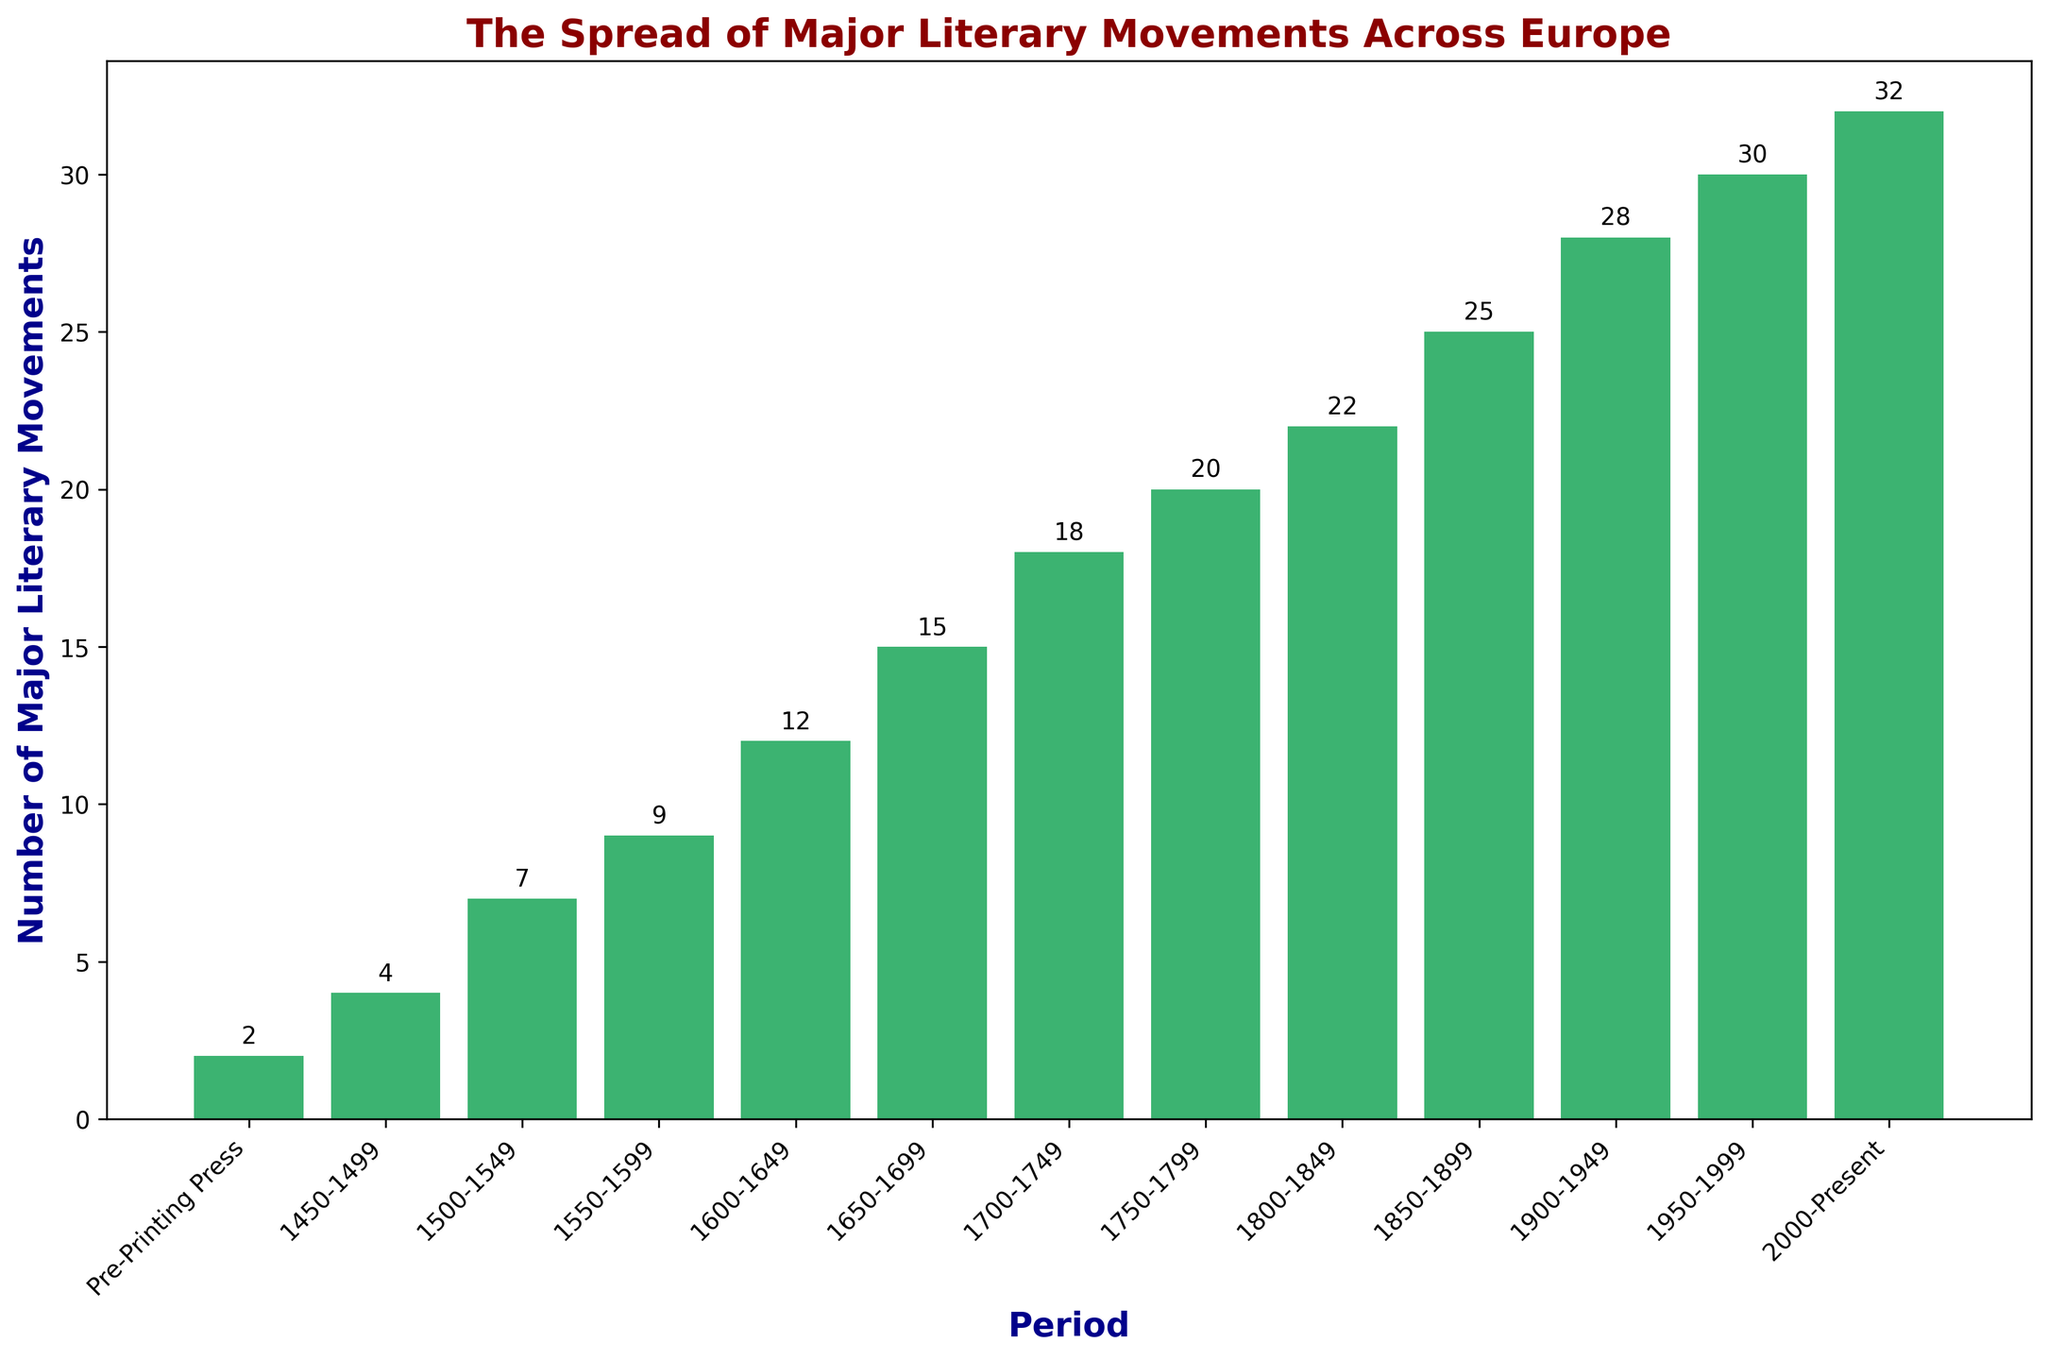What period has the highest number of major literary movements? To answer this, look at the bar with the greatest height. The tallest bar corresponds to the 2000-Present period with 32 movements. Therefore, the highest number of major literary movements is in the 2000-Present period.
Answer: 2000-Present In which period did the number of major literary movements triple compared to the Pre-Printing Press period? The Pre-Printing Press period has 2 movements. To find when it triples (2 * 3 = 6), look for the period with 6 movements. The period closest to this number is 1500-1549, which has 7 movements. Hence, during the 1500-1549 period, the number of major literary movements tripled relative to the Pre-Printing Press period.
Answer: 1500-1549 How many periods have more than 20 major literary movements? Identify the bars with heights exceeding 20. The periods 1850-1899, 1900-1949, 1950-1999, and 2000-Present all have bars taller than 20. Counting these periods gives us 4 periods.
Answer: 4 What is the total number of major literary movements from 1600 to 1849? Sum the movements in the periods from 1600-1649, 1650-1699, 1700-1749, 1750-1799, and 1800-1849. These are 12 + 15 + 18 + 20 + 22 respectively. Summing them gives 12 + 15 + 18 + 20 + 22 = 87.
Answer: 87 How many more major literary movements are there in the 20th century (1900-1999) compared to the 16th century (1500-1599)? Compare the total number of movements in 1900-1999 (28 + 30) to those in 1500-1599 (7 + 9). First, sum the movements: 1900-1999 has 58 and 1500-1599 has 16. The difference is 58 - 16 = 42.
Answer: 42 Compare the increase in major literary movements from 1450-1499 to 1500-1549 to the increase from 1950-1999 to 2000-Present. Which increase is larger? From 1450-1499 to 1500-1549, movements go from 4 to 7, an increase of 3. From 1950-1999 to 2000-Present, movements go from 30 to 32, an increase of 2. The increase is larger in the earlier period (3 vs. 2).
Answer: 1450-1549 Which period marks the first time the number of major literary movements surpasses 10? Look for when the movements first exceed a height of 10. This occurs in the period 1600-1649 with 12 movements.
Answer: 1600-1649 Is there any period where the number of major literary movements did not increase compared to the preceding period? Examine each pair of adjacent bars. Every subsequent bar shows a higher number of movements than the previous one, indicating consistent growth without stagnation or decline.
Answer: No 